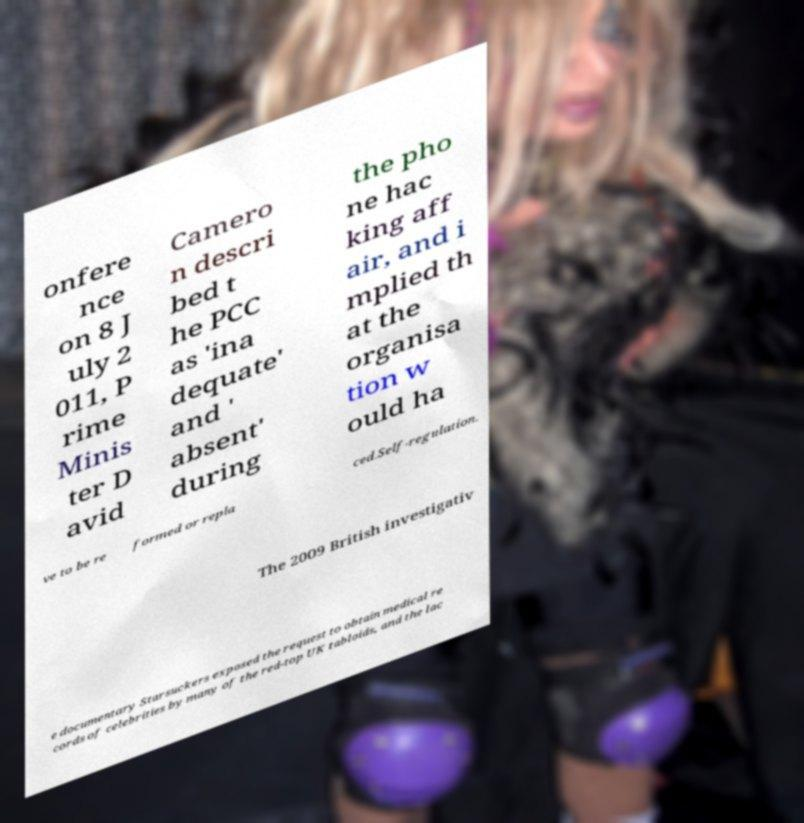Please identify and transcribe the text found in this image. onfere nce on 8 J uly 2 011, P rime Minis ter D avid Camero n descri bed t he PCC as 'ina dequate' and ' absent' during the pho ne hac king aff air, and i mplied th at the organisa tion w ould ha ve to be re formed or repla ced.Self-regulation. The 2009 British investigativ e documentary Starsuckers exposed the request to obtain medical re cords of celebrities by many of the red-top UK tabloids, and the lac 